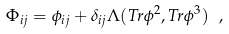Convert formula to latex. <formula><loc_0><loc_0><loc_500><loc_500>\Phi _ { i j } = \phi _ { i j } + \delta _ { i j } \Lambda ( T r \phi ^ { 2 } , T r \phi ^ { 3 } ) \ ,</formula> 